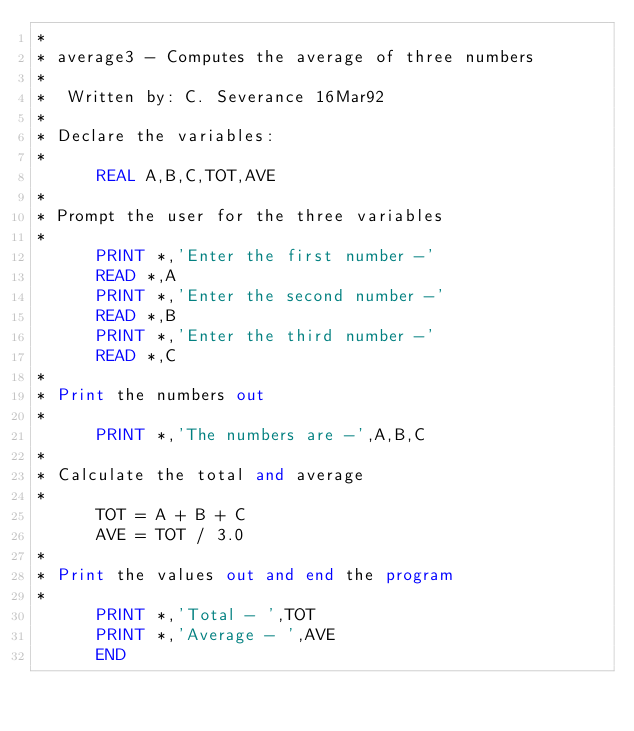<code> <loc_0><loc_0><loc_500><loc_500><_FORTRAN_>*
* average3 - Computes the average of three numbers
*
*  Written by: C. Severance 16Mar92
*
* Declare the variables:
*
      REAL A,B,C,TOT,AVE
*
* Prompt the user for the three variables
*
      PRINT *,'Enter the first number -'
      READ *,A
      PRINT *,'Enter the second number -'
      READ *,B
      PRINT *,'Enter the third number -'
      READ *,C
*
* Print the numbers out
*
      PRINT *,'The numbers are -',A,B,C
*
* Calculate the total and average
*
      TOT = A + B + C
      AVE = TOT / 3.0
*
* Print the values out and end the program
*
      PRINT *,'Total - ',TOT
      PRINT *,'Average - ',AVE
      END
</code> 